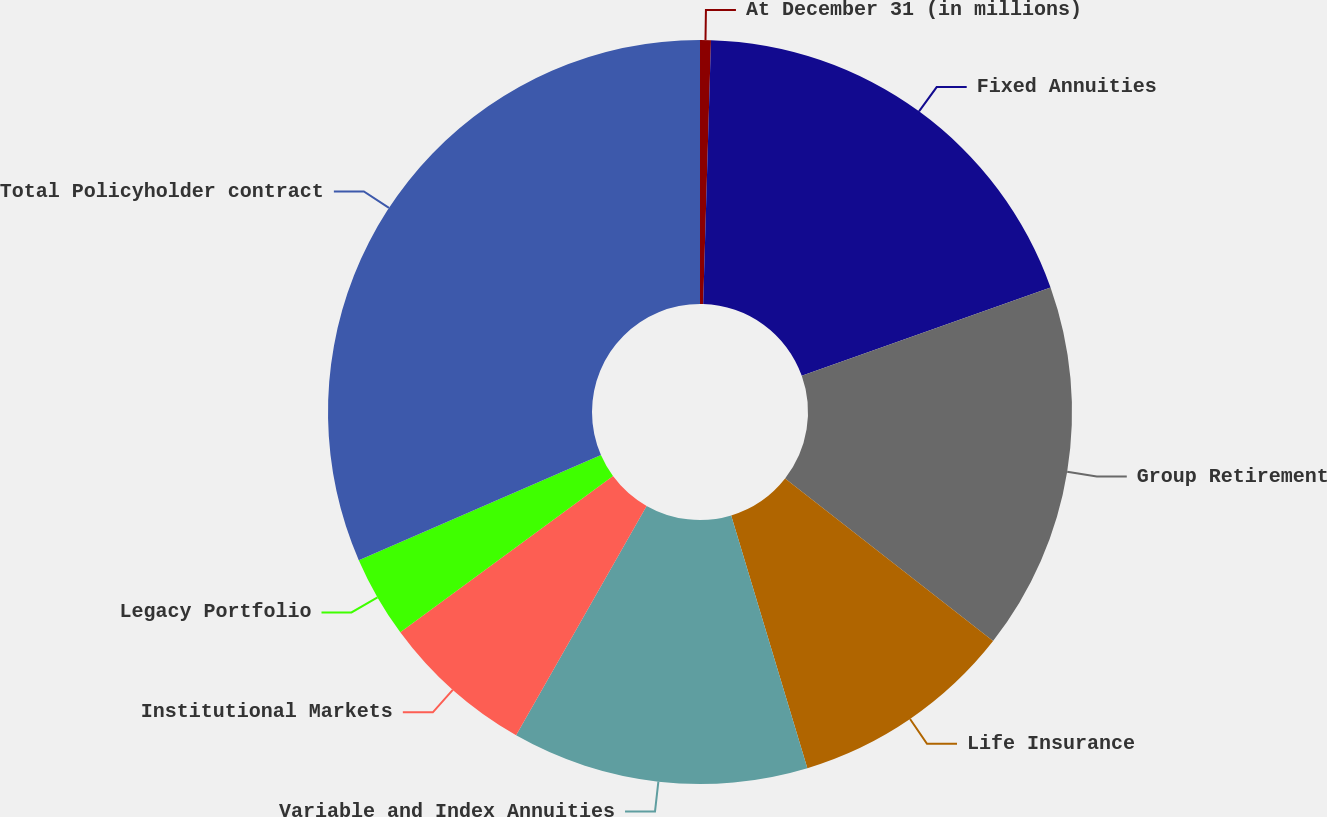Convert chart. <chart><loc_0><loc_0><loc_500><loc_500><pie_chart><fcel>At December 31 (in millions)<fcel>Fixed Annuities<fcel>Group Retirement<fcel>Life Insurance<fcel>Variable and Index Annuities<fcel>Institutional Markets<fcel>Legacy Portfolio<fcel>Total Policyholder contract<nl><fcel>0.47%<fcel>19.1%<fcel>15.99%<fcel>9.78%<fcel>12.89%<fcel>6.68%<fcel>3.57%<fcel>31.52%<nl></chart> 